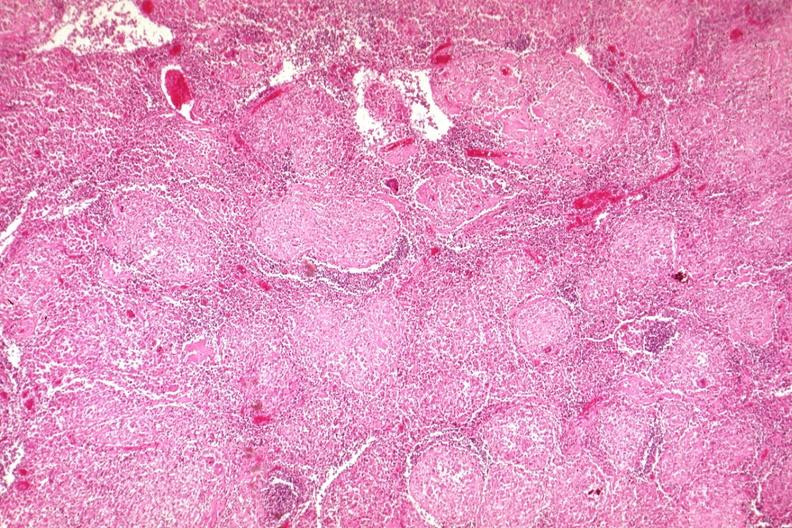s very good example present?
Answer the question using a single word or phrase. No 